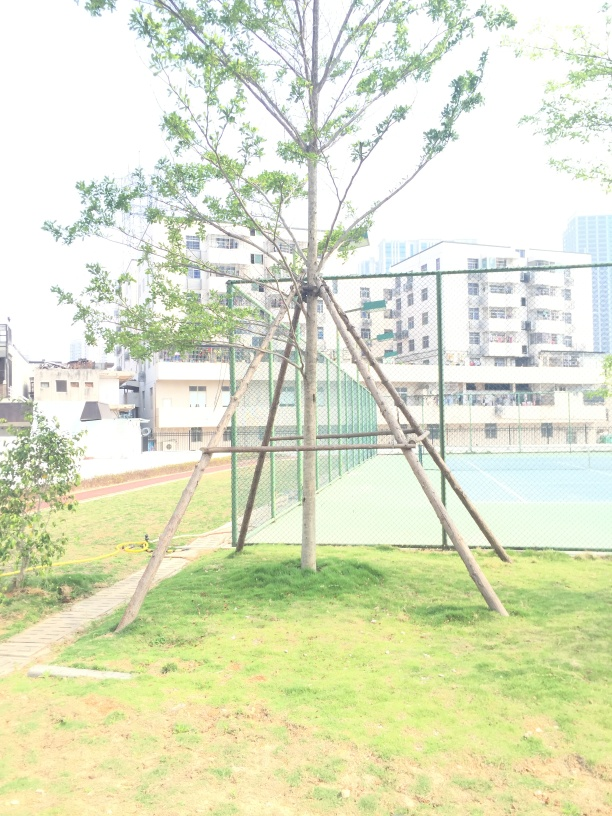Are there any quality issues with this image? The image appears overexposed, with brightness levels that obscure details and reduce the visual clarity. The high exposure affects the contrast and makes it difficult to see the finer characteristics of the surroundings, such as the grass's texture or the buildings in the background. 